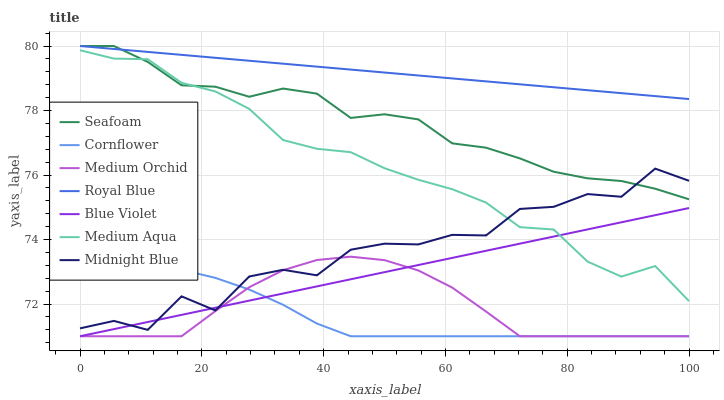Does Cornflower have the minimum area under the curve?
Answer yes or no. Yes. Does Royal Blue have the maximum area under the curve?
Answer yes or no. Yes. Does Midnight Blue have the minimum area under the curve?
Answer yes or no. No. Does Midnight Blue have the maximum area under the curve?
Answer yes or no. No. Is Blue Violet the smoothest?
Answer yes or no. Yes. Is Midnight Blue the roughest?
Answer yes or no. Yes. Is Medium Orchid the smoothest?
Answer yes or no. No. Is Medium Orchid the roughest?
Answer yes or no. No. Does Cornflower have the lowest value?
Answer yes or no. Yes. Does Midnight Blue have the lowest value?
Answer yes or no. No. Does Royal Blue have the highest value?
Answer yes or no. Yes. Does Midnight Blue have the highest value?
Answer yes or no. No. Is Blue Violet less than Seafoam?
Answer yes or no. Yes. Is Royal Blue greater than Midnight Blue?
Answer yes or no. Yes. Does Medium Orchid intersect Cornflower?
Answer yes or no. Yes. Is Medium Orchid less than Cornflower?
Answer yes or no. No. Is Medium Orchid greater than Cornflower?
Answer yes or no. No. Does Blue Violet intersect Seafoam?
Answer yes or no. No. 